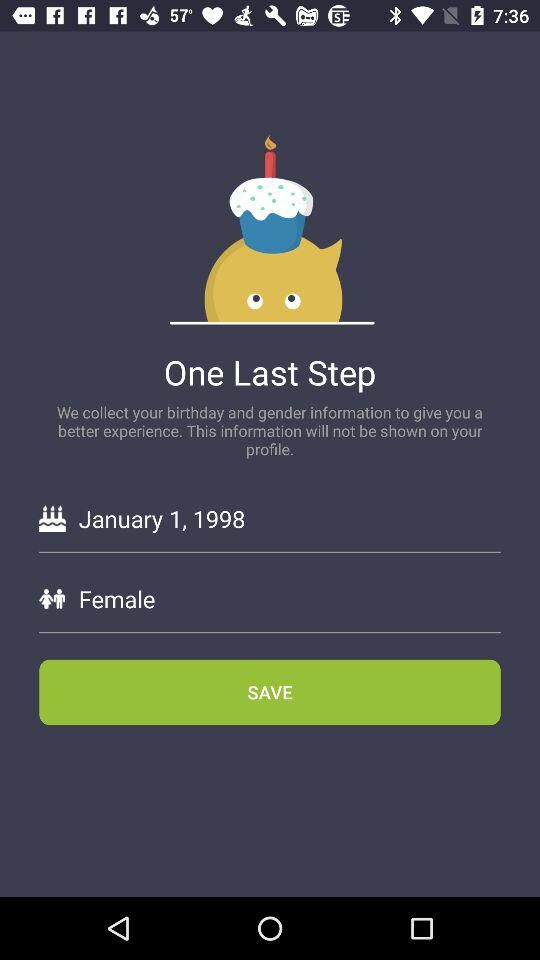Which gender is selected? The selected gender is female. 